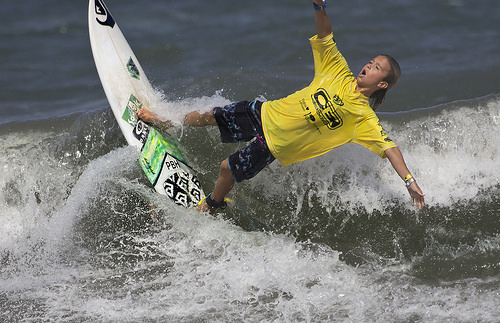<image>
Is the surfer on the board? Yes. Looking at the image, I can see the surfer is positioned on top of the board, with the board providing support. 